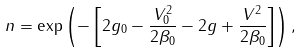Convert formula to latex. <formula><loc_0><loc_0><loc_500><loc_500>n = \exp \left ( - \left [ 2 g _ { 0 } - \frac { V ^ { 2 } _ { 0 } } { 2 \beta _ { 0 } } - 2 g + \frac { V ^ { 2 } } { 2 \beta _ { 0 } } \right ] \right ) ,</formula> 